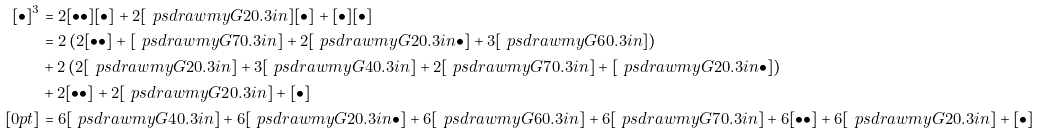Convert formula to latex. <formula><loc_0><loc_0><loc_500><loc_500>[ \bullet ] ^ { 3 } & = 2 [ \bullet \bullet ] [ \bullet ] + 2 [ \ p s d r a w { m y G 2 } { 0 . 3 i n } ] [ \bullet ] + [ \bullet ] [ \bullet ] \\ & = 2 \, ( 2 [ \bullet \bullet ] + [ \ p s d r a w { m y G 7 } { 0 . 3 i n } ] + 2 [ \ p s d r a w { m y G 2 } { 0 . 3 i n } \bullet ] + 3 [ \ p s d r a w { m y G 6 } { 0 . 3 i n } ] ) \\ & + 2 \, ( 2 [ \ p s d r a w { m y G 2 } { 0 . 3 i n } ] + 3 [ \ p s d r a w { m y G 4 } { 0 . 3 i n } ] + 2 [ \ p s d r a w { m y G 7 } { 0 . 3 i n } ] + [ \ p s d r a w { m y G 2 } { 0 . 3 i n } \bullet ] ) \\ & + 2 [ \bullet \bullet ] + 2 [ \ p s d r a w { m y G 2 } { 0 . 3 i n } ] + [ \bullet ] \\ [ 0 p t ] & = 6 [ \ p s d r a w { m y G 4 } { 0 . 3 i n } ] + 6 [ \ p s d r a w { m y G 2 } { 0 . 3 i n } \bullet ] + 6 [ \ p s d r a w { m y G 6 } { 0 . 3 i n } ] + 6 [ \ p s d r a w { m y G 7 } { 0 . 3 i n } ] + 6 [ \bullet \bullet ] + 6 [ \ p s d r a w { m y G 2 } { 0 . 3 i n } ] + [ \bullet ]</formula> 